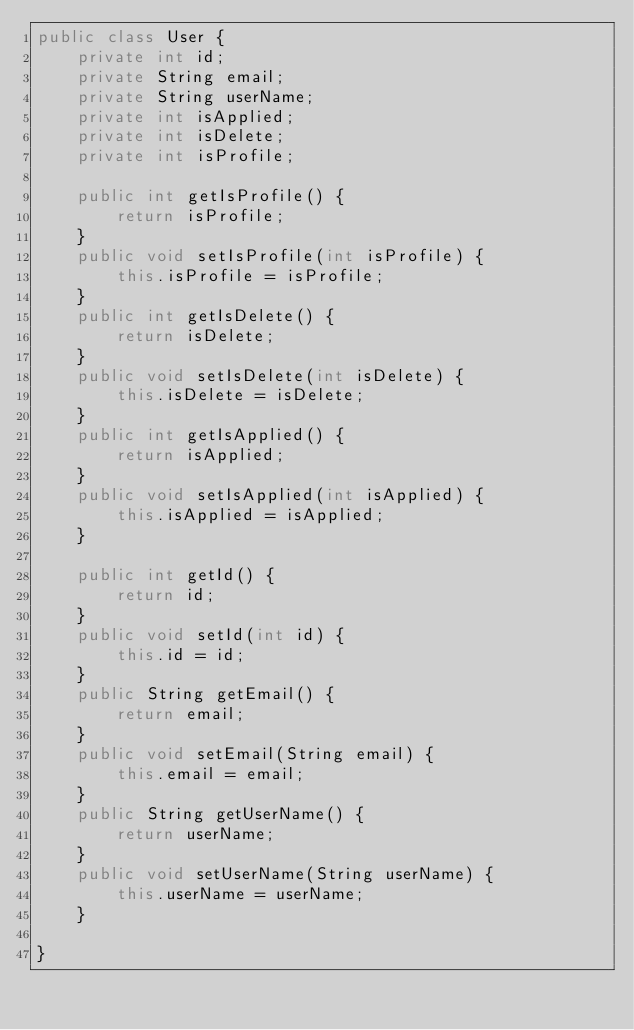<code> <loc_0><loc_0><loc_500><loc_500><_Java_>public class User {
	private int id;
	private String email;
	private String userName;
	private int isApplied;
	private int isDelete;
	private int isProfile;
	
	public int getIsProfile() {
		return isProfile;
	}
	public void setIsProfile(int isProfile) {
		this.isProfile = isProfile;
	}
	public int getIsDelete() {
		return isDelete;
	}
	public void setIsDelete(int isDelete) {
		this.isDelete = isDelete;
	}
	public int getIsApplied() {
		return isApplied;
	}
	public void setIsApplied(int isApplied) {
		this.isApplied = isApplied;
	}

	public int getId() {
		return id;
	}
	public void setId(int id) {
		this.id = id;
	}
	public String getEmail() {
		return email;
	}
	public void setEmail(String email) {
		this.email = email;
	}
	public String getUserName() {
		return userName;
	}
	public void setUserName(String userName) {
		this.userName = userName;
	}

}
</code> 